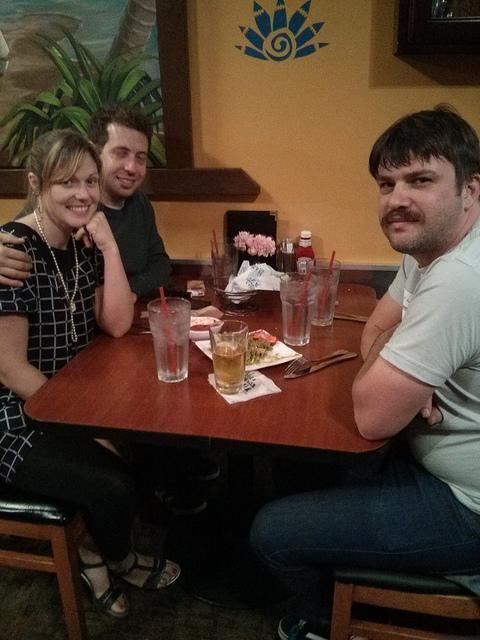How many glasses of water on the table?
Give a very brief answer. 3. How many people are wearing glasses?
Give a very brief answer. 0. How many people in the photo?
Give a very brief answer. 3. How many people are there?
Give a very brief answer. 3. How many chairs are there?
Give a very brief answer. 2. How many cups are visible?
Give a very brief answer. 3. How many black sheep are there?
Give a very brief answer. 0. 